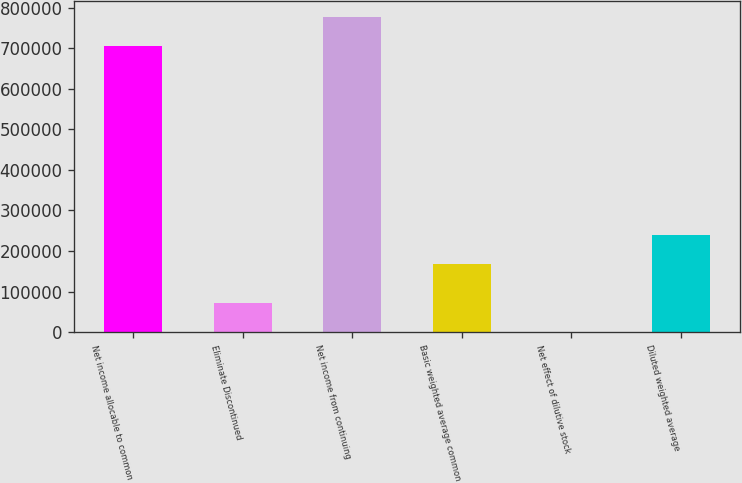<chart> <loc_0><loc_0><loc_500><loc_500><bar_chart><fcel>Net income allocable to common<fcel>Eliminate Discontinued<fcel>Net income from continuing<fcel>Basic weighted average common<fcel>Net effect of dilutive stock<fcel>Diluted weighted average<nl><fcel>705803<fcel>71727.7<fcel>777106<fcel>168250<fcel>425<fcel>239553<nl></chart> 